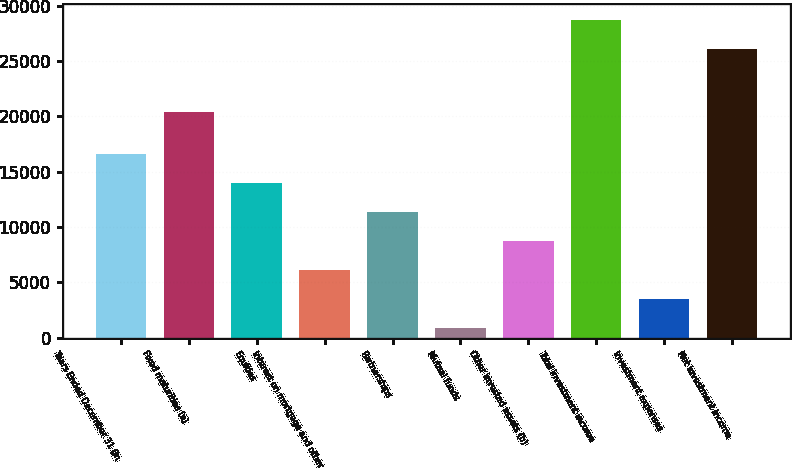<chart> <loc_0><loc_0><loc_500><loc_500><bar_chart><fcel>Years Ended December 31 (in<fcel>Fixed maturities (a)<fcel>Equities<fcel>Interest on mortgage and other<fcel>Partnerships<fcel>Mutual funds<fcel>Other invested assets (b)<fcel>Total investment income<fcel>Investment expenses<fcel>Net investment income<nl><fcel>16605.8<fcel>20393<fcel>13979<fcel>6098.6<fcel>11352.2<fcel>845<fcel>8725.4<fcel>28696.8<fcel>3471.8<fcel>26070<nl></chart> 